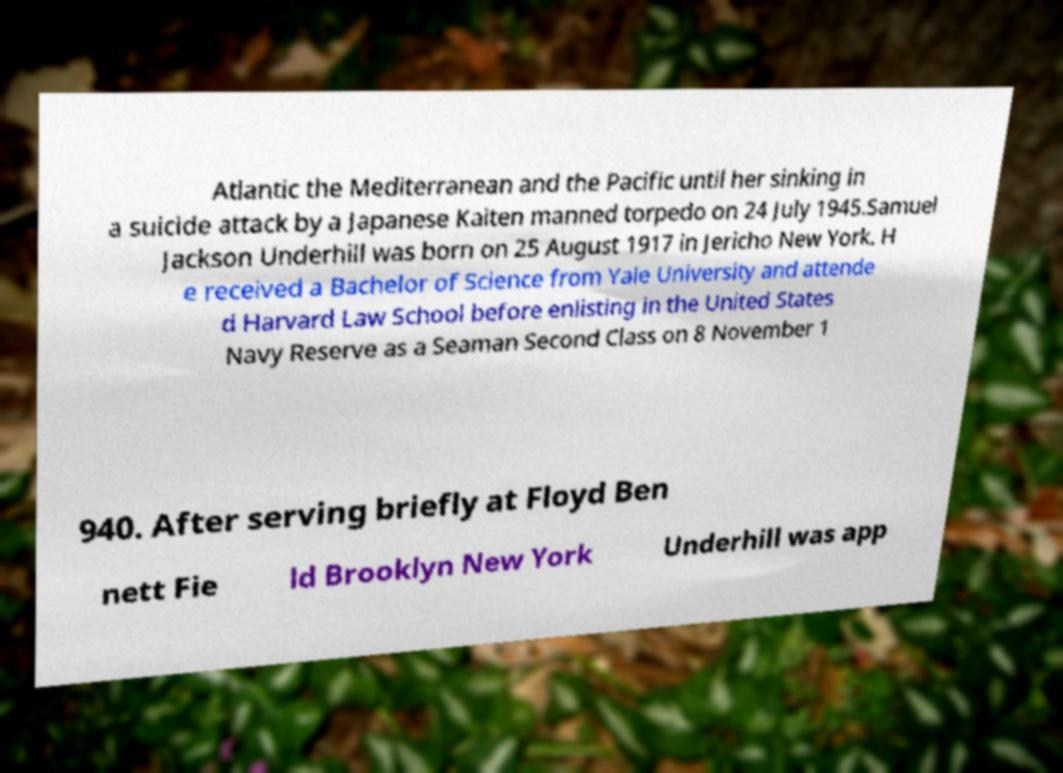Please identify and transcribe the text found in this image. Atlantic the Mediterranean and the Pacific until her sinking in a suicide attack by a Japanese Kaiten manned torpedo on 24 July 1945.Samuel Jackson Underhill was born on 25 August 1917 in Jericho New York. H e received a Bachelor of Science from Yale University and attende d Harvard Law School before enlisting in the United States Navy Reserve as a Seaman Second Class on 8 November 1 940. After serving briefly at Floyd Ben nett Fie ld Brooklyn New York Underhill was app 